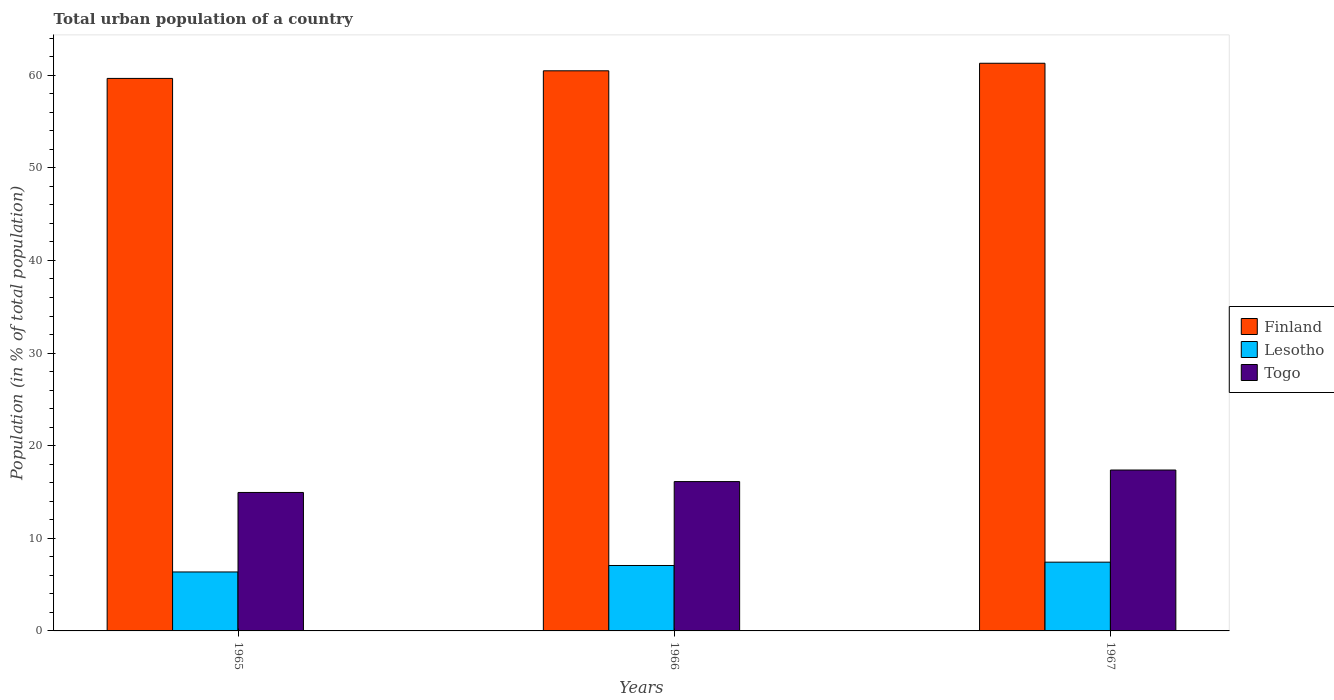How many bars are there on the 3rd tick from the left?
Offer a very short reply. 3. What is the label of the 1st group of bars from the left?
Offer a terse response. 1965. In how many cases, is the number of bars for a given year not equal to the number of legend labels?
Your response must be concise. 0. What is the urban population in Finland in 1966?
Ensure brevity in your answer.  60.48. Across all years, what is the maximum urban population in Lesotho?
Provide a succinct answer. 7.42. Across all years, what is the minimum urban population in Finland?
Ensure brevity in your answer.  59.66. In which year was the urban population in Lesotho maximum?
Make the answer very short. 1967. In which year was the urban population in Togo minimum?
Provide a short and direct response. 1965. What is the total urban population in Togo in the graph?
Make the answer very short. 48.45. What is the difference between the urban population in Lesotho in 1966 and that in 1967?
Provide a succinct answer. -0.36. What is the average urban population in Togo per year?
Provide a succinct answer. 16.15. In the year 1966, what is the difference between the urban population in Lesotho and urban population in Togo?
Offer a terse response. -9.06. What is the ratio of the urban population in Lesotho in 1965 to that in 1967?
Your answer should be compact. 0.86. Is the urban population in Lesotho in 1966 less than that in 1967?
Provide a succinct answer. Yes. What is the difference between the highest and the second highest urban population in Togo?
Offer a terse response. 1.25. What is the difference between the highest and the lowest urban population in Togo?
Ensure brevity in your answer.  2.42. In how many years, is the urban population in Togo greater than the average urban population in Togo taken over all years?
Offer a very short reply. 1. Is the sum of the urban population in Lesotho in 1965 and 1967 greater than the maximum urban population in Finland across all years?
Offer a terse response. No. What does the 1st bar from the left in 1967 represents?
Make the answer very short. Finland. What does the 3rd bar from the right in 1966 represents?
Offer a terse response. Finland. Is it the case that in every year, the sum of the urban population in Togo and urban population in Finland is greater than the urban population in Lesotho?
Your answer should be compact. Yes. What is the difference between two consecutive major ticks on the Y-axis?
Give a very brief answer. 10. Does the graph contain any zero values?
Give a very brief answer. No. Where does the legend appear in the graph?
Your response must be concise. Center right. What is the title of the graph?
Your answer should be compact. Total urban population of a country. What is the label or title of the X-axis?
Your answer should be compact. Years. What is the label or title of the Y-axis?
Your response must be concise. Population (in % of total population). What is the Population (in % of total population) of Finland in 1965?
Your response must be concise. 59.66. What is the Population (in % of total population) of Lesotho in 1965?
Your answer should be very brief. 6.37. What is the Population (in % of total population) in Togo in 1965?
Give a very brief answer. 14.95. What is the Population (in % of total population) in Finland in 1966?
Ensure brevity in your answer.  60.48. What is the Population (in % of total population) in Lesotho in 1966?
Your answer should be very brief. 7.07. What is the Population (in % of total population) of Togo in 1966?
Offer a very short reply. 16.12. What is the Population (in % of total population) of Finland in 1967?
Offer a terse response. 61.3. What is the Population (in % of total population) in Lesotho in 1967?
Make the answer very short. 7.42. What is the Population (in % of total population) in Togo in 1967?
Your answer should be compact. 17.37. Across all years, what is the maximum Population (in % of total population) of Finland?
Your answer should be compact. 61.3. Across all years, what is the maximum Population (in % of total population) in Lesotho?
Keep it short and to the point. 7.42. Across all years, what is the maximum Population (in % of total population) in Togo?
Keep it short and to the point. 17.37. Across all years, what is the minimum Population (in % of total population) of Finland?
Provide a succinct answer. 59.66. Across all years, what is the minimum Population (in % of total population) of Lesotho?
Provide a short and direct response. 6.37. Across all years, what is the minimum Population (in % of total population) of Togo?
Your answer should be compact. 14.95. What is the total Population (in % of total population) in Finland in the graph?
Keep it short and to the point. 181.43. What is the total Population (in % of total population) in Lesotho in the graph?
Offer a very short reply. 20.86. What is the total Population (in % of total population) in Togo in the graph?
Give a very brief answer. 48.45. What is the difference between the Population (in % of total population) in Finland in 1965 and that in 1966?
Keep it short and to the point. -0.82. What is the difference between the Population (in % of total population) of Lesotho in 1965 and that in 1966?
Keep it short and to the point. -0.7. What is the difference between the Population (in % of total population) of Togo in 1965 and that in 1966?
Ensure brevity in your answer.  -1.18. What is the difference between the Population (in % of total population) of Finland in 1965 and that in 1967?
Your answer should be very brief. -1.64. What is the difference between the Population (in % of total population) in Lesotho in 1965 and that in 1967?
Ensure brevity in your answer.  -1.06. What is the difference between the Population (in % of total population) in Togo in 1965 and that in 1967?
Offer a terse response. -2.42. What is the difference between the Population (in % of total population) of Finland in 1966 and that in 1967?
Keep it short and to the point. -0.81. What is the difference between the Population (in % of total population) of Lesotho in 1966 and that in 1967?
Make the answer very short. -0.36. What is the difference between the Population (in % of total population) in Togo in 1966 and that in 1967?
Give a very brief answer. -1.25. What is the difference between the Population (in % of total population) of Finland in 1965 and the Population (in % of total population) of Lesotho in 1966?
Provide a short and direct response. 52.59. What is the difference between the Population (in % of total population) of Finland in 1965 and the Population (in % of total population) of Togo in 1966?
Offer a very short reply. 43.53. What is the difference between the Population (in % of total population) in Lesotho in 1965 and the Population (in % of total population) in Togo in 1966?
Your answer should be compact. -9.76. What is the difference between the Population (in % of total population) in Finland in 1965 and the Population (in % of total population) in Lesotho in 1967?
Ensure brevity in your answer.  52.23. What is the difference between the Population (in % of total population) of Finland in 1965 and the Population (in % of total population) of Togo in 1967?
Offer a very short reply. 42.28. What is the difference between the Population (in % of total population) in Lesotho in 1965 and the Population (in % of total population) in Togo in 1967?
Keep it short and to the point. -11.01. What is the difference between the Population (in % of total population) of Finland in 1966 and the Population (in % of total population) of Lesotho in 1967?
Your answer should be very brief. 53.05. What is the difference between the Population (in % of total population) of Finland in 1966 and the Population (in % of total population) of Togo in 1967?
Provide a succinct answer. 43.11. What is the difference between the Population (in % of total population) in Lesotho in 1966 and the Population (in % of total population) in Togo in 1967?
Your answer should be very brief. -10.31. What is the average Population (in % of total population) in Finland per year?
Provide a short and direct response. 60.48. What is the average Population (in % of total population) in Lesotho per year?
Provide a succinct answer. 6.95. What is the average Population (in % of total population) of Togo per year?
Give a very brief answer. 16.15. In the year 1965, what is the difference between the Population (in % of total population) in Finland and Population (in % of total population) in Lesotho?
Your answer should be compact. 53.29. In the year 1965, what is the difference between the Population (in % of total population) of Finland and Population (in % of total population) of Togo?
Offer a very short reply. 44.71. In the year 1965, what is the difference between the Population (in % of total population) in Lesotho and Population (in % of total population) in Togo?
Ensure brevity in your answer.  -8.58. In the year 1966, what is the difference between the Population (in % of total population) in Finland and Population (in % of total population) in Lesotho?
Offer a terse response. 53.41. In the year 1966, what is the difference between the Population (in % of total population) in Finland and Population (in % of total population) in Togo?
Your response must be concise. 44.35. In the year 1966, what is the difference between the Population (in % of total population) in Lesotho and Population (in % of total population) in Togo?
Offer a very short reply. -9.06. In the year 1967, what is the difference between the Population (in % of total population) in Finland and Population (in % of total population) in Lesotho?
Offer a terse response. 53.87. In the year 1967, what is the difference between the Population (in % of total population) in Finland and Population (in % of total population) in Togo?
Make the answer very short. 43.92. In the year 1967, what is the difference between the Population (in % of total population) of Lesotho and Population (in % of total population) of Togo?
Provide a succinct answer. -9.95. What is the ratio of the Population (in % of total population) of Finland in 1965 to that in 1966?
Provide a succinct answer. 0.99. What is the ratio of the Population (in % of total population) in Lesotho in 1965 to that in 1966?
Keep it short and to the point. 0.9. What is the ratio of the Population (in % of total population) in Togo in 1965 to that in 1966?
Provide a succinct answer. 0.93. What is the ratio of the Population (in % of total population) of Finland in 1965 to that in 1967?
Offer a terse response. 0.97. What is the ratio of the Population (in % of total population) of Lesotho in 1965 to that in 1967?
Provide a short and direct response. 0.86. What is the ratio of the Population (in % of total population) in Togo in 1965 to that in 1967?
Keep it short and to the point. 0.86. What is the ratio of the Population (in % of total population) in Finland in 1966 to that in 1967?
Provide a succinct answer. 0.99. What is the ratio of the Population (in % of total population) in Lesotho in 1966 to that in 1967?
Keep it short and to the point. 0.95. What is the ratio of the Population (in % of total population) in Togo in 1966 to that in 1967?
Offer a terse response. 0.93. What is the difference between the highest and the second highest Population (in % of total population) of Finland?
Your answer should be compact. 0.81. What is the difference between the highest and the second highest Population (in % of total population) in Lesotho?
Your answer should be compact. 0.36. What is the difference between the highest and the second highest Population (in % of total population) in Togo?
Your answer should be compact. 1.25. What is the difference between the highest and the lowest Population (in % of total population) of Finland?
Your response must be concise. 1.64. What is the difference between the highest and the lowest Population (in % of total population) in Lesotho?
Give a very brief answer. 1.06. What is the difference between the highest and the lowest Population (in % of total population) of Togo?
Offer a terse response. 2.42. 